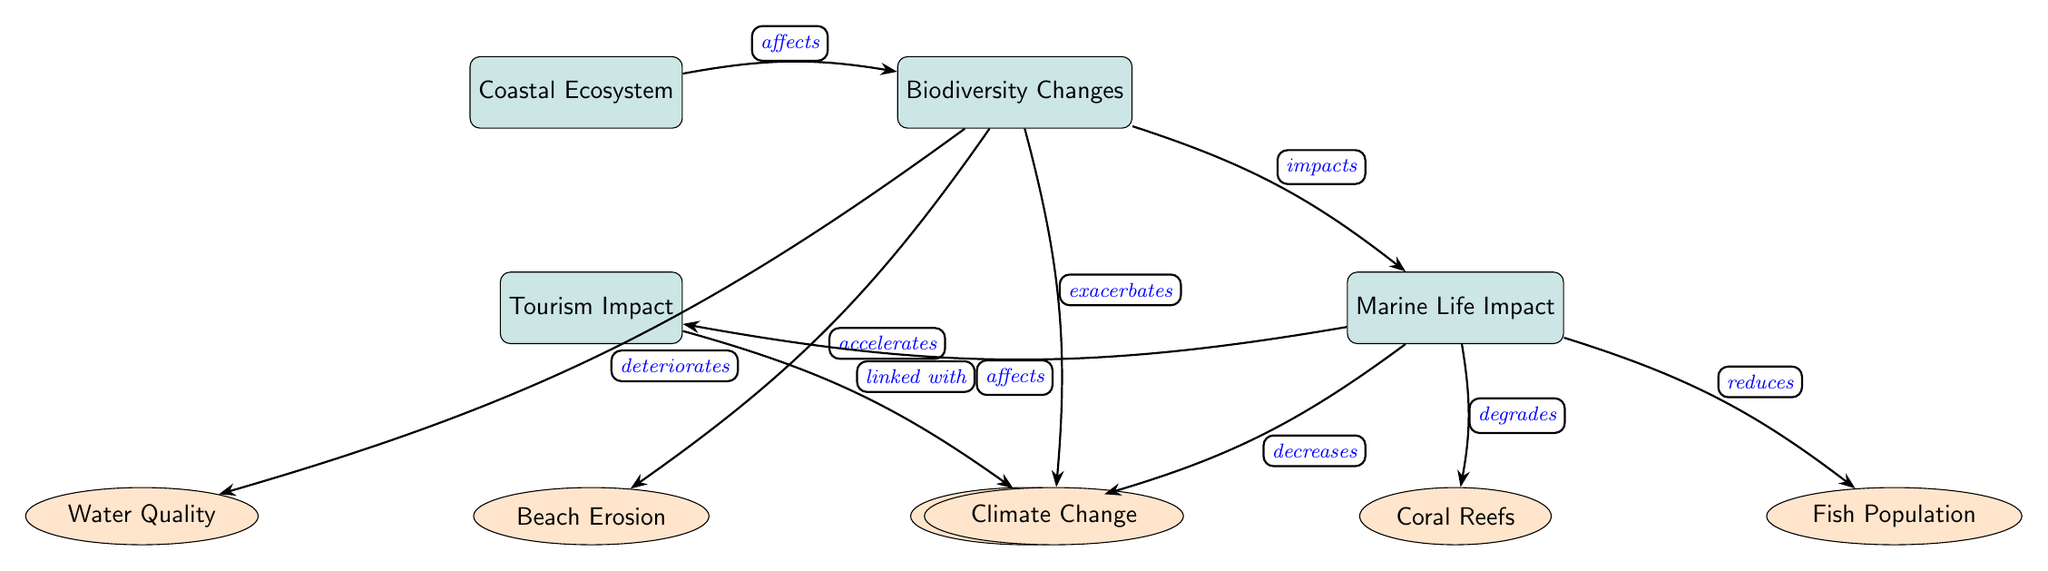What is the main focus of the diagram? The diagram focuses on the relationship between Coastal Ecosystems and their impacts on Biodiversity, Local Marine Life, and Tourism. It visually represents various factors and their interconnections.
Answer: Coastal Ecosystem How many nodes are present in the diagram? To determine the number of nodes, count all the distinct elements in the diagram. This includes the main nodes and sub-nodes: Coastal Ecosystem, Biodiversity Changes, Marine Life Impact, Tourism Impact, Coral Reefs, Fish Population, Seagrass Beds, Beach Erosion, Water Quality, and Climate Change, totaling ten nodes.
Answer: 10 What type of impact does Biodiversity Changes have on Tourism Impact? The diagram indicates that Biodiversity Changes "affects" Tourism Impact, highlighting a direct connection between ecological changes and tourism consequences.
Answer: affects Which sub-node is directly linked to Marine Life Impact? Marine Life Impact has three direct sub-nodes: Coral Reefs, Fish Population, and Seagrass Beds that are impacted due to the changes in biodiversity.
Answer: Coral Reefs What are the effects of Biodiversity Changes on Water Quality? The diagram shows that Biodiversity Changes "deteriorates" Water Quality, indicating a negative relationship where shifts in biodiversity lead to declines in the quality of water.
Answer: deteriorates Explain the relationship between Climate Change and Tourism Impact. Climate Change has a linked impact on Tourism Impact, as indicated by the diagram showing that changes related to climate directly affect tourism, likely through environmental shifts that alter tourist experiences.
Answer: linked with How do Biodiversity Changes impact Coral Reefs? According to the diagram, Biodiversity Changes directly "degrades" Coral Reefs, pointing to the harmful effects ecological shifts can have on this critical marine ecosystem component.
Answer: degrades Describe the flow from Coastal Ecosystem to Beach Erosion. The flow from Coastal Ecosystem starts with its effect on Biodiversity Changes, which then leads to the impact of Biodiversity Changes "accelerating" Beach Erosion, demonstrating how ecological shifts contribute to coastal issues.
Answer: accelerates 